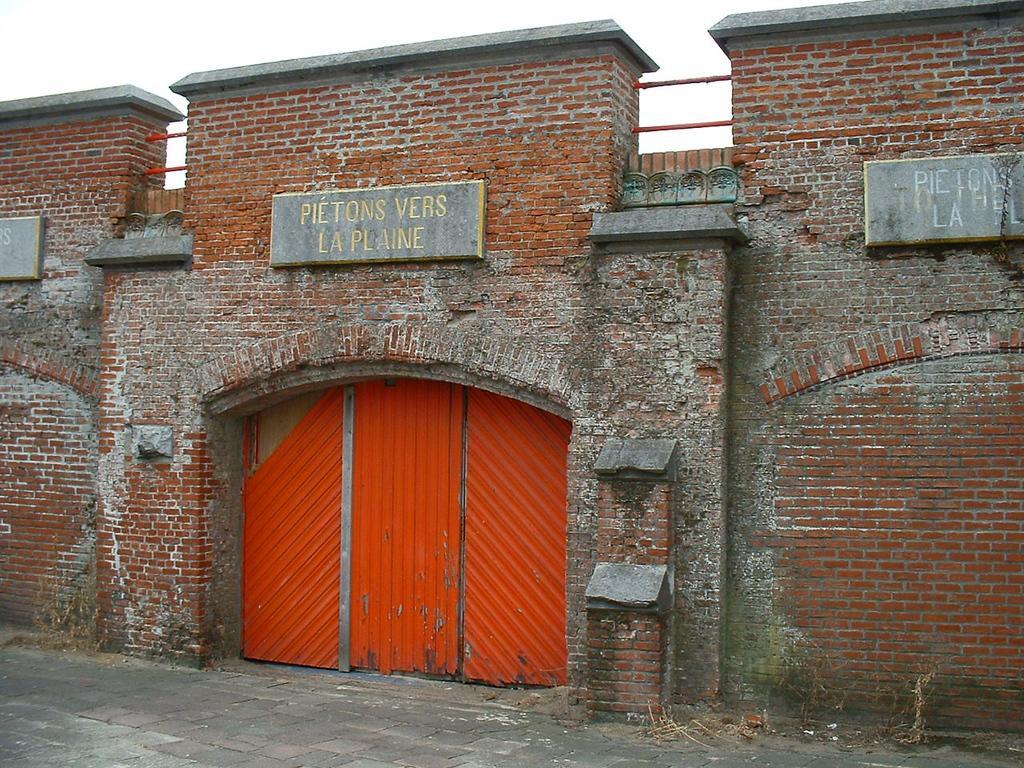Can you describe this image briefly? This image consists of a wall along with a gate. The gate is in red color. At the bottom, there is a road. And we can see the name boards. At the top, there is sky. 